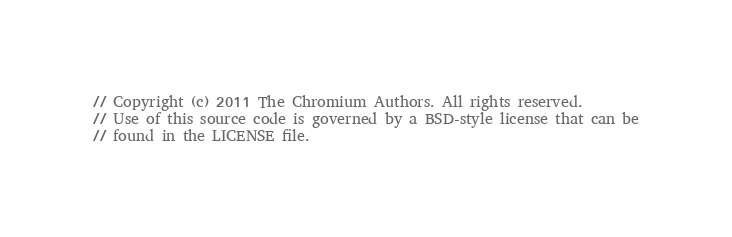Convert code to text. <code><loc_0><loc_0><loc_500><loc_500><_ObjectiveC_>// Copyright (c) 2011 The Chromium Authors. All rights reserved.
// Use of this source code is governed by a BSD-style license that can be
// found in the LICENSE file.
</code> 